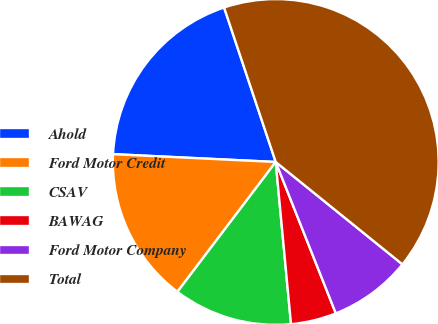Convert chart. <chart><loc_0><loc_0><loc_500><loc_500><pie_chart><fcel>Ahold<fcel>Ford Motor Credit<fcel>CSAV<fcel>BAWAG<fcel>Ford Motor Company<fcel>Total<nl><fcel>19.1%<fcel>15.45%<fcel>11.81%<fcel>4.52%<fcel>8.17%<fcel>40.95%<nl></chart> 